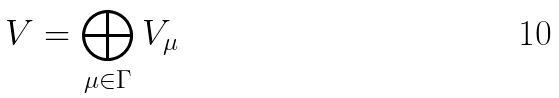Convert formula to latex. <formula><loc_0><loc_0><loc_500><loc_500>V = \bigoplus _ { \mu \in \Gamma } V _ { \mu }</formula> 